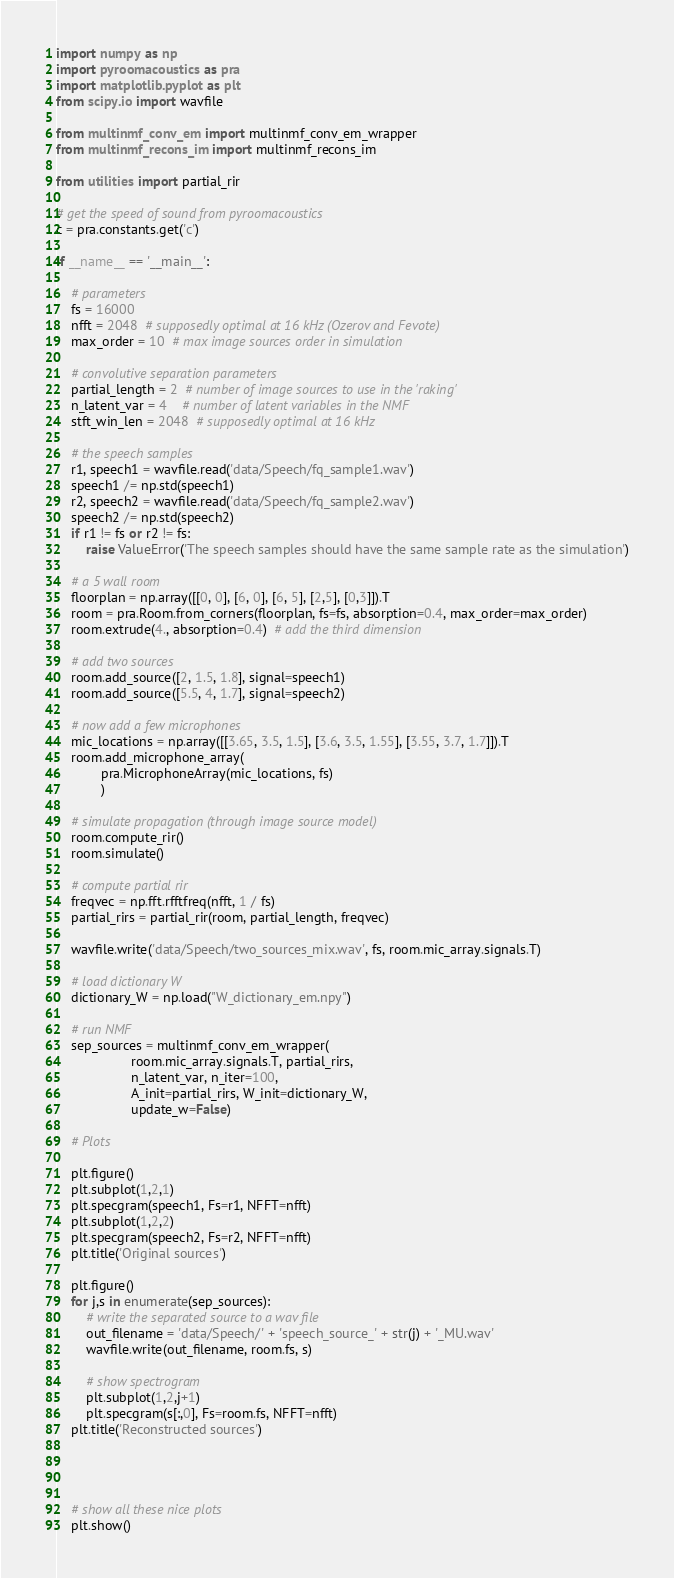Convert code to text. <code><loc_0><loc_0><loc_500><loc_500><_Python_>
import numpy as np
import pyroomacoustics as pra
import matplotlib.pyplot as plt
from scipy.io import wavfile

from multinmf_conv_em import multinmf_conv_em_wrapper
from multinmf_recons_im import multinmf_recons_im

from utilities import partial_rir

# get the speed of sound from pyroomacoustics
c = pra.constants.get('c')

if __name__ == '__main__':

    # parameters
    fs = 16000
    nfft = 2048  # supposedly optimal at 16 kHz (Ozerov and Fevote)
    max_order = 10  # max image sources order in simulation

    # convolutive separation parameters
    partial_length = 2  # number of image sources to use in the 'raking'
    n_latent_var = 4    # number of latent variables in the NMF
    stft_win_len = 2048  # supposedly optimal at 16 kHz

    # the speech samples
    r1, speech1 = wavfile.read('data/Speech/fq_sample1.wav')
    speech1 /= np.std(speech1)
    r2, speech2 = wavfile.read('data/Speech/fq_sample2.wav')
    speech2 /= np.std(speech2)
    if r1 != fs or r2 != fs:
        raise ValueError('The speech samples should have the same sample rate as the simulation')

    # a 5 wall room
    floorplan = np.array([[0, 0], [6, 0], [6, 5], [2,5], [0,3]]).T
    room = pra.Room.from_corners(floorplan, fs=fs, absorption=0.4, max_order=max_order)
    room.extrude(4., absorption=0.4)  # add the third dimension

    # add two sources
    room.add_source([2, 1.5, 1.8], signal=speech1)
    room.add_source([5.5, 4, 1.7], signal=speech2)

    # now add a few microphones
    mic_locations = np.array([[3.65, 3.5, 1.5], [3.6, 3.5, 1.55], [3.55, 3.7, 1.7]]).T
    room.add_microphone_array(
            pra.MicrophoneArray(mic_locations, fs)
            )

    # simulate propagation (through image source model)
    room.compute_rir()
    room.simulate()

    # compute partial rir
    freqvec = np.fft.rfftfreq(nfft, 1 / fs)
    partial_rirs = partial_rir(room, partial_length, freqvec)

    wavfile.write('data/Speech/two_sources_mix.wav', fs, room.mic_array.signals.T)

    # load dictionary W
    dictionary_W = np.load("W_dictionary_em.npy")

    # run NMF
    sep_sources = multinmf_conv_em_wrapper(
                    room.mic_array.signals.T, partial_rirs,
                    n_latent_var, n_iter=100,
                    A_init=partial_rirs, W_init=dictionary_W,
                    update_w=False)

    # Plots

    plt.figure()
    plt.subplot(1,2,1)
    plt.specgram(speech1, Fs=r1, NFFT=nfft)
    plt.subplot(1,2,2)
    plt.specgram(speech2, Fs=r2, NFFT=nfft)
    plt.title('Original sources')

    plt.figure()
    for j,s in enumerate(sep_sources):
        # write the separated source to a wav file
        out_filename = 'data/Speech/' + 'speech_source_' + str(j) + '_MU.wav'
        wavfile.write(out_filename, room.fs, s)

        # show spectrogram
        plt.subplot(1,2,j+1)
        plt.specgram(s[:,0], Fs=room.fs, NFFT=nfft)
    plt.title('Reconstructed sources')




    # show all these nice plots
    plt.show()
</code> 